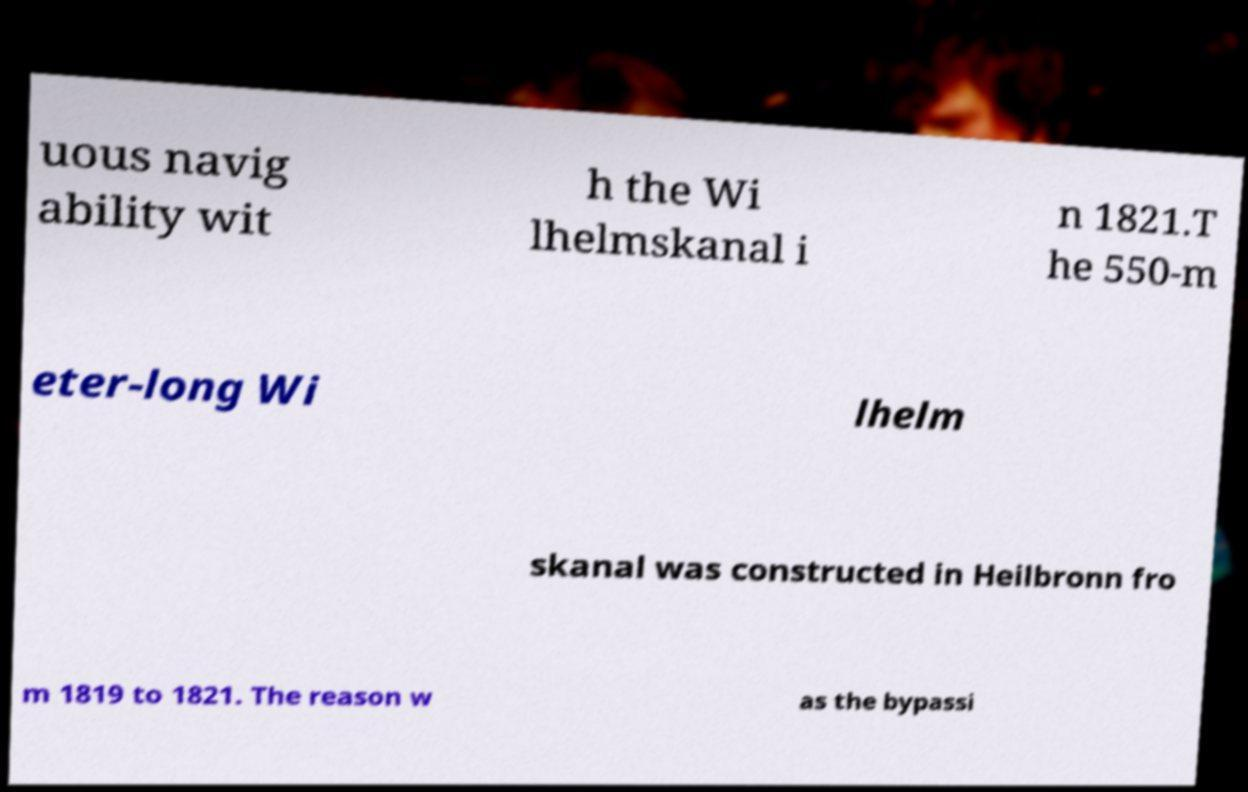Could you assist in decoding the text presented in this image and type it out clearly? uous navig ability wit h the Wi lhelmskanal i n 1821.T he 550-m eter-long Wi lhelm skanal was constructed in Heilbronn fro m 1819 to 1821. The reason w as the bypassi 